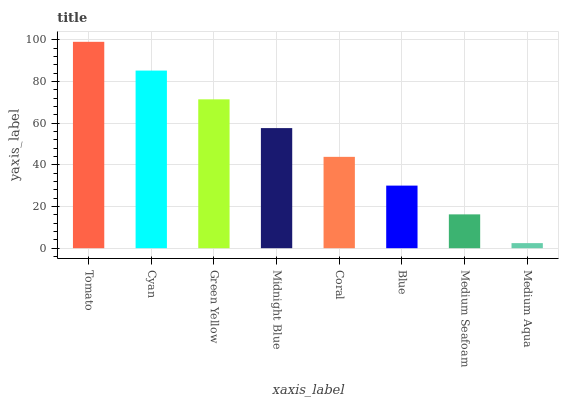Is Medium Aqua the minimum?
Answer yes or no. Yes. Is Tomato the maximum?
Answer yes or no. Yes. Is Cyan the minimum?
Answer yes or no. No. Is Cyan the maximum?
Answer yes or no. No. Is Tomato greater than Cyan?
Answer yes or no. Yes. Is Cyan less than Tomato?
Answer yes or no. Yes. Is Cyan greater than Tomato?
Answer yes or no. No. Is Tomato less than Cyan?
Answer yes or no. No. Is Midnight Blue the high median?
Answer yes or no. Yes. Is Coral the low median?
Answer yes or no. Yes. Is Green Yellow the high median?
Answer yes or no. No. Is Cyan the low median?
Answer yes or no. No. 